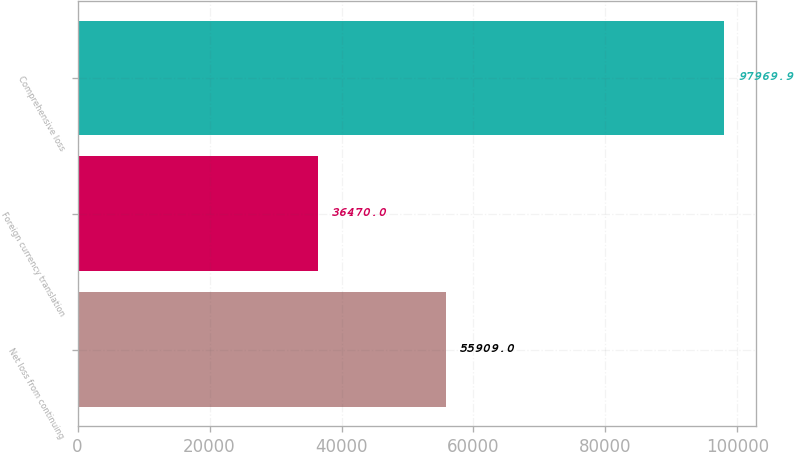Convert chart. <chart><loc_0><loc_0><loc_500><loc_500><bar_chart><fcel>Net loss from continuing<fcel>Foreign currency translation<fcel>Comprehensive loss<nl><fcel>55909<fcel>36470<fcel>97969.9<nl></chart> 